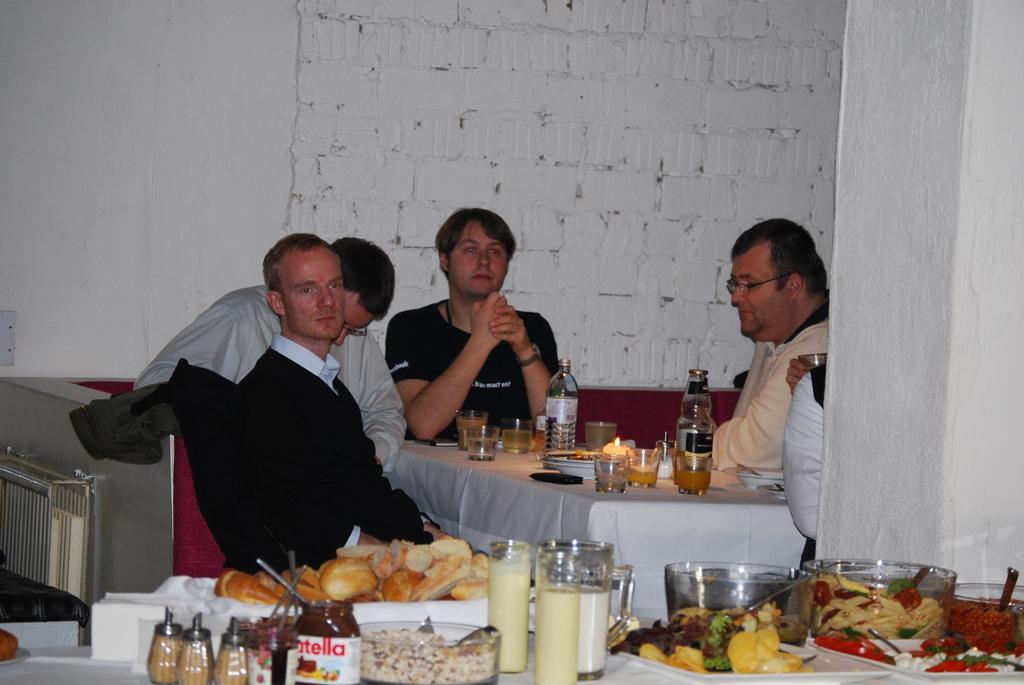What hazelnut spread brand is on the table?
Provide a short and direct response. Nutella. 